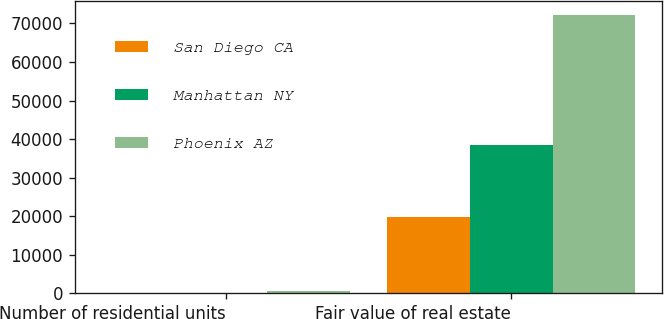<chart> <loc_0><loc_0><loc_500><loc_500><stacked_bar_chart><ecel><fcel>Number of residential units<fcel>Fair value of real estate<nl><fcel>San Diego CA<fcel>84<fcel>19814<nl><fcel>Manhattan NY<fcel>42<fcel>38423<nl><fcel>Phoenix AZ<fcel>488<fcel>72310<nl></chart> 